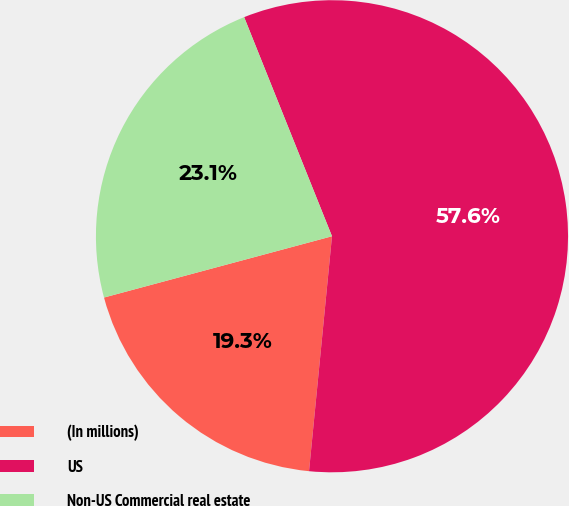Convert chart to OTSL. <chart><loc_0><loc_0><loc_500><loc_500><pie_chart><fcel>(In millions)<fcel>US<fcel>Non-US Commercial real estate<nl><fcel>19.27%<fcel>57.62%<fcel>23.11%<nl></chart> 